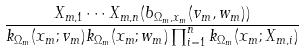<formula> <loc_0><loc_0><loc_500><loc_500>\frac { X _ { m , 1 } \cdots X _ { m , n } ( b _ { \Omega _ { m } , x _ { m } } ( v _ { m } , w _ { m } ) ) } { k _ { \Omega _ { m } } ( x _ { m } ; v _ { m } ) k _ { \Omega _ { m } } ( x _ { m } ; w _ { m } ) \prod _ { i = 1 } ^ { n } k _ { \Omega _ { m } } ( x _ { m } ; X _ { m , i } ) }</formula> 